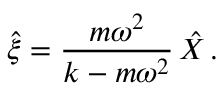Convert formula to latex. <formula><loc_0><loc_0><loc_500><loc_500>\hat { \xi } = \frac { m \omega ^ { 2 } } { k - m \omega ^ { 2 } } \, \hat { X } \, .</formula> 